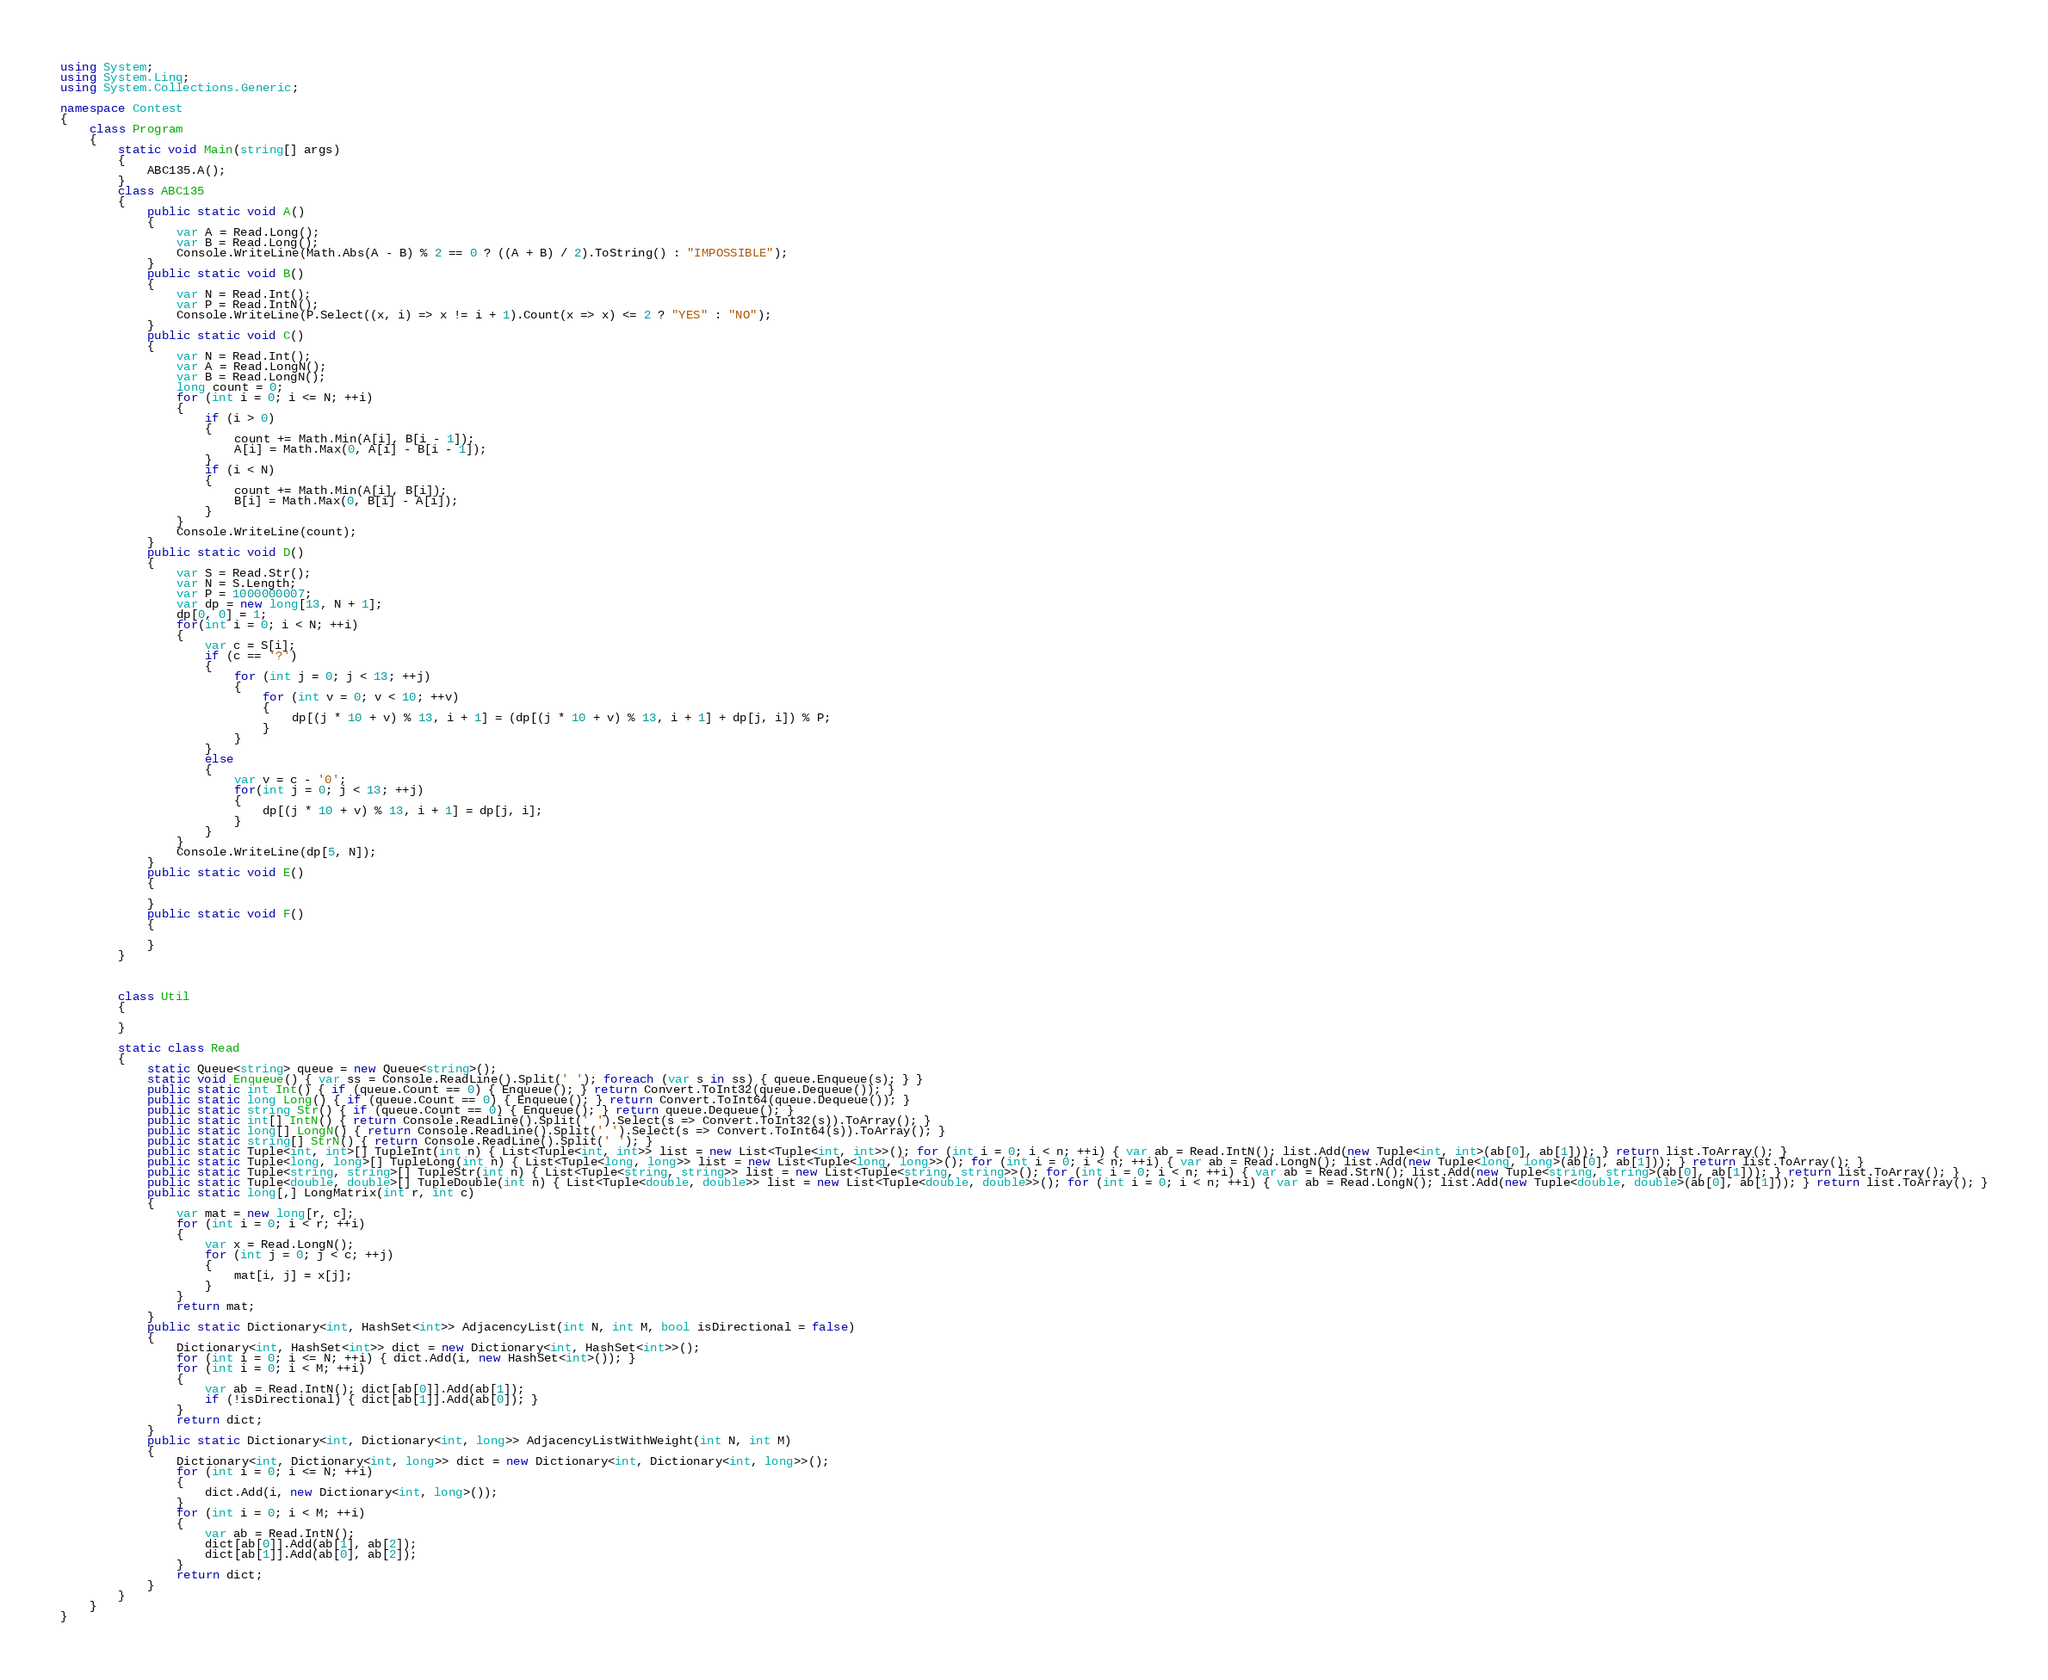Convert code to text. <code><loc_0><loc_0><loc_500><loc_500><_C#_>using System;
using System.Linq;
using System.Collections.Generic;

namespace Contest
{
    class Program
    {
        static void Main(string[] args)
        {
            ABC135.A();
        }
        class ABC135
        {
            public static void A()
            {
                var A = Read.Long();
                var B = Read.Long();
                Console.WriteLine(Math.Abs(A - B) % 2 == 0 ? ((A + B) / 2).ToString() : "IMPOSSIBLE");
            }
            public static void B()
            {
                var N = Read.Int();
                var P = Read.IntN();
                Console.WriteLine(P.Select((x, i) => x != i + 1).Count(x => x) <= 2 ? "YES" : "NO");
            }
            public static void C()
            {
                var N = Read.Int();
                var A = Read.LongN();
                var B = Read.LongN();
                long count = 0;
                for (int i = 0; i <= N; ++i)
                {
                    if (i > 0)
                    {
                        count += Math.Min(A[i], B[i - 1]);
                        A[i] = Math.Max(0, A[i] - B[i - 1]);
                    }
                    if (i < N)
                    {
                        count += Math.Min(A[i], B[i]);
                        B[i] = Math.Max(0, B[i] - A[i]);
                    }
                }
                Console.WriteLine(count);
            }
            public static void D()
            {
                var S = Read.Str();
                var N = S.Length;
                var P = 1000000007;
                var dp = new long[13, N + 1];
                dp[0, 0] = 1;
                for(int i = 0; i < N; ++i)
                {
                    var c = S[i];
                    if (c == '?')
                    {
                        for (int j = 0; j < 13; ++j)
                        {
                            for (int v = 0; v < 10; ++v)
                            {
                                dp[(j * 10 + v) % 13, i + 1] = (dp[(j * 10 + v) % 13, i + 1] + dp[j, i]) % P;
                            }
                        }
                    }
                    else
                    {
                        var v = c - '0';
                        for(int j = 0; j < 13; ++j)
                        {
                            dp[(j * 10 + v) % 13, i + 1] = dp[j, i];
                        }
                    }
                }
                Console.WriteLine(dp[5, N]);
            }
            public static void E()
            {

            }
            public static void F()
            {

            }
        }



        class Util
        {

        }

        static class Read
        {
            static Queue<string> queue = new Queue<string>();
            static void Enqueue() { var ss = Console.ReadLine().Split(' '); foreach (var s in ss) { queue.Enqueue(s); } }
            public static int Int() { if (queue.Count == 0) { Enqueue(); } return Convert.ToInt32(queue.Dequeue()); }
            public static long Long() { if (queue.Count == 0) { Enqueue(); } return Convert.ToInt64(queue.Dequeue()); }
            public static string Str() { if (queue.Count == 0) { Enqueue(); } return queue.Dequeue(); }
            public static int[] IntN() { return Console.ReadLine().Split(' ').Select(s => Convert.ToInt32(s)).ToArray(); }
            public static long[] LongN() { return Console.ReadLine().Split(' ').Select(s => Convert.ToInt64(s)).ToArray(); }
            public static string[] StrN() { return Console.ReadLine().Split(' '); }
            public static Tuple<int, int>[] TupleInt(int n) { List<Tuple<int, int>> list = new List<Tuple<int, int>>(); for (int i = 0; i < n; ++i) { var ab = Read.IntN(); list.Add(new Tuple<int, int>(ab[0], ab[1])); } return list.ToArray(); }
            public static Tuple<long, long>[] TupleLong(int n) { List<Tuple<long, long>> list = new List<Tuple<long, long>>(); for (int i = 0; i < n; ++i) { var ab = Read.LongN(); list.Add(new Tuple<long, long>(ab[0], ab[1])); } return list.ToArray(); }
            public static Tuple<string, string>[] TupleStr(int n) { List<Tuple<string, string>> list = new List<Tuple<string, string>>(); for (int i = 0; i < n; ++i) { var ab = Read.StrN(); list.Add(new Tuple<string, string>(ab[0], ab[1])); } return list.ToArray(); }
            public static Tuple<double, double>[] TupleDouble(int n) { List<Tuple<double, double>> list = new List<Tuple<double, double>>(); for (int i = 0; i < n; ++i) { var ab = Read.LongN(); list.Add(new Tuple<double, double>(ab[0], ab[1])); } return list.ToArray(); }
            public static long[,] LongMatrix(int r, int c)
            {
                var mat = new long[r, c];
                for (int i = 0; i < r; ++i)
                {
                    var x = Read.LongN();
                    for (int j = 0; j < c; ++j)
                    {
                        mat[i, j] = x[j];
                    }
                }
                return mat;
            }
            public static Dictionary<int, HashSet<int>> AdjacencyList(int N, int M, bool isDirectional = false)
            {
                Dictionary<int, HashSet<int>> dict = new Dictionary<int, HashSet<int>>();
                for (int i = 0; i <= N; ++i) { dict.Add(i, new HashSet<int>()); }
                for (int i = 0; i < M; ++i)
                {
                    var ab = Read.IntN(); dict[ab[0]].Add(ab[1]);
                    if (!isDirectional) { dict[ab[1]].Add(ab[0]); }
                }
                return dict;
            }
            public static Dictionary<int, Dictionary<int, long>> AdjacencyListWithWeight(int N, int M)
            {
                Dictionary<int, Dictionary<int, long>> dict = new Dictionary<int, Dictionary<int, long>>();
                for (int i = 0; i <= N; ++i)
                {
                    dict.Add(i, new Dictionary<int, long>());
                }
                for (int i = 0; i < M; ++i)
                {
                    var ab = Read.IntN();
                    dict[ab[0]].Add(ab[1], ab[2]);
                    dict[ab[1]].Add(ab[0], ab[2]);
                }
                return dict;
            }
        }
    }
}
</code> 